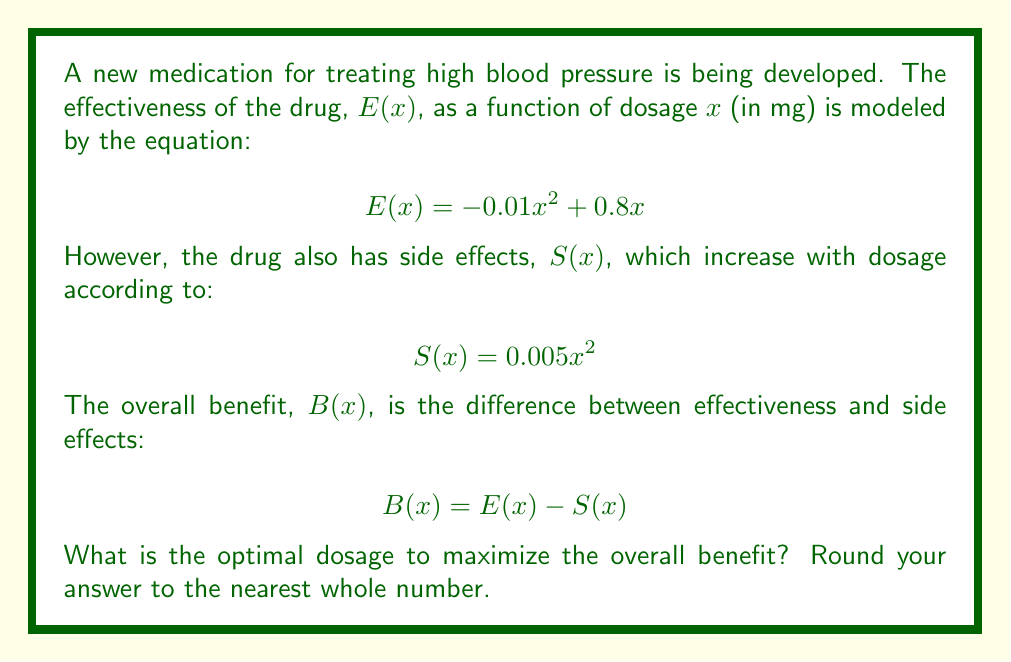Can you answer this question? To find the optimal dosage, we need to maximize the benefit function $B(x)$. Let's approach this step-by-step:

1) First, let's express $B(x)$ in terms of $x$:
   $$B(x) = E(x) - S(x)$$
   $$B(x) = (-0.01x^2 + 0.8x) - (0.005x^2)$$
   $$B(x) = -0.015x^2 + 0.8x$$

2) To find the maximum of this quadratic function, we need to find where its derivative equals zero:
   $$\frac{d}{dx}B(x) = -0.03x + 0.8$$

3) Set this equal to zero and solve for $x$:
   $$-0.03x + 0.8 = 0$$
   $$-0.03x = -0.8$$
   $$x = \frac{-0.8}{-0.03} = \frac{80}{3} \approx 26.67$$

4) To confirm this is a maximum (not a minimum), we can check the second derivative:
   $$\frac{d^2}{dx^2}B(x) = -0.03$$
   Since this is negative, we confirm that $x = \frac{80}{3}$ gives a maximum.

5) Rounding to the nearest whole number, we get 27 mg.
Answer: 27 mg 